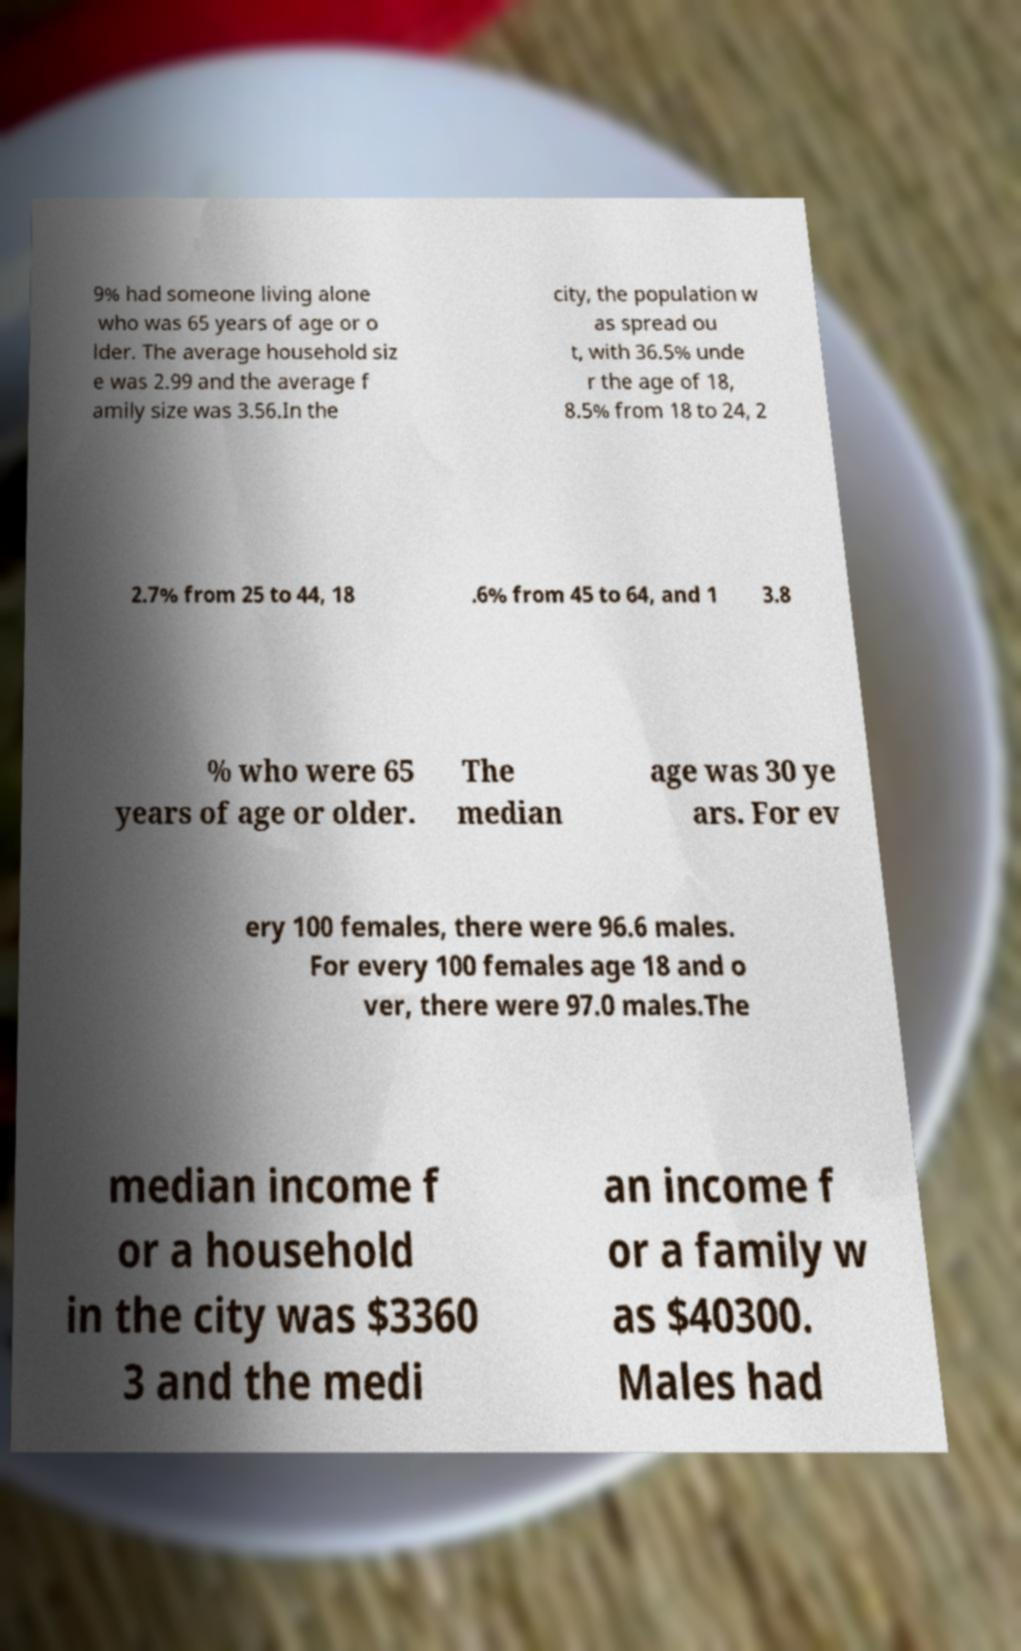There's text embedded in this image that I need extracted. Can you transcribe it verbatim? 9% had someone living alone who was 65 years of age or o lder. The average household siz e was 2.99 and the average f amily size was 3.56.In the city, the population w as spread ou t, with 36.5% unde r the age of 18, 8.5% from 18 to 24, 2 2.7% from 25 to 44, 18 .6% from 45 to 64, and 1 3.8 % who were 65 years of age or older. The median age was 30 ye ars. For ev ery 100 females, there were 96.6 males. For every 100 females age 18 and o ver, there were 97.0 males.The median income f or a household in the city was $3360 3 and the medi an income f or a family w as $40300. Males had 